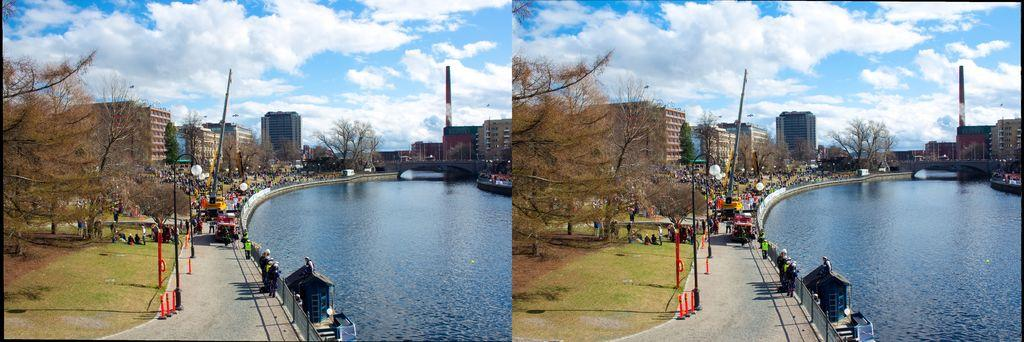What type of artwork is the image? The image is a collage. What can be seen on the right side of the image? There is water on the right side of the image. What type of vegetation is present in the image? There are trees in the image. What type of structures can be seen in the background of the image? There are buildings in the background of the image. What type of ground cover is visible in the image? There is grass visible in the image. What type of barrier is present in the image? There is a fencing in the image. Reasoning: Let' Let's think step by step in order to produce the conversation. We start by identifying the type of artwork, which is a collage. Then, we describe the various elements present in the image, such as water, trees, buildings, grass, and fencing. Each question is designed to elicit a specific detail about the image that is known from the provided facts. Absurd Question/Answer: What type of receipt can be seen in the image? There is no receipt present in the image. What type of quiver is visible in the image? There is no quiver present in the image. What type of bulb is visible in the image? There is no bulb present in the image. 